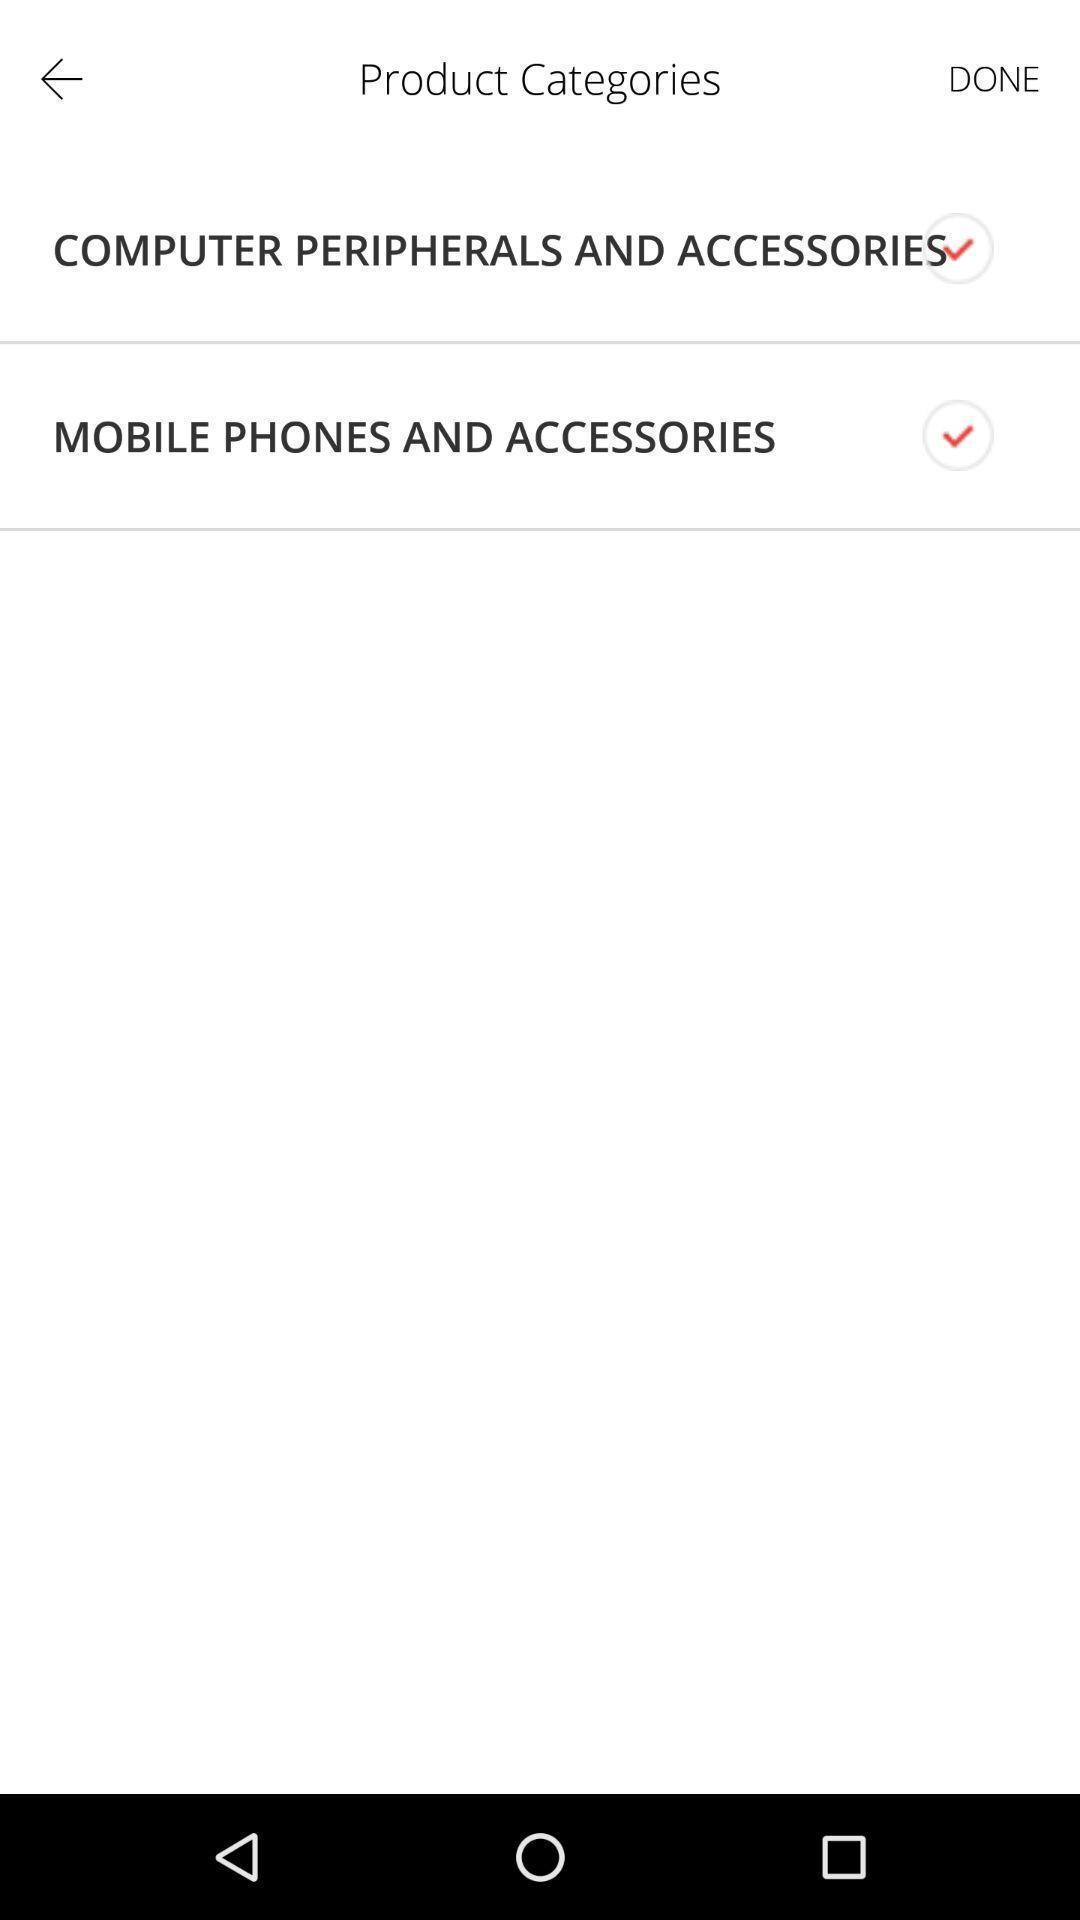Provide a description of this screenshot. Page showing the options for product categories. 